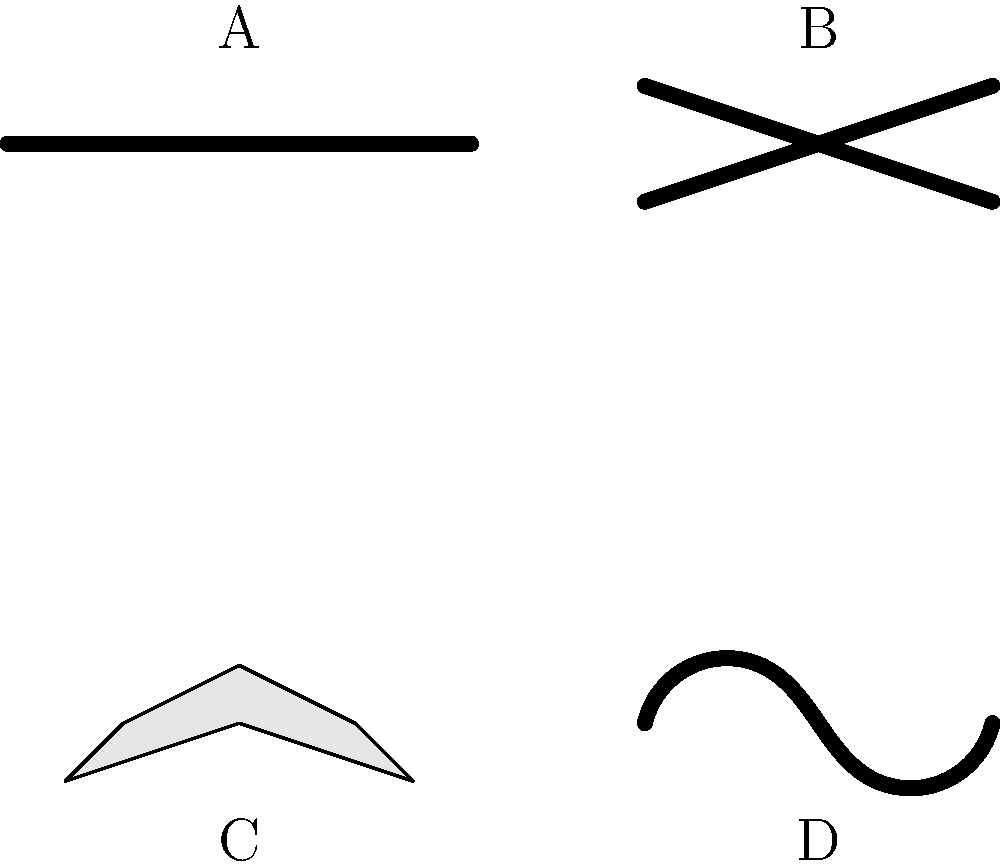As a chef, you understand the importance of pasta shapes in various dishes. Based on the visual appearance of the pasta shapes shown in the image, which one would be best suited for a hearty meat sauce due to its ability to hold the sauce well? To determine which pasta shape is best suited for a hearty meat sauce, we need to consider the characteristics of each shape and how they interact with sauce:

1. Shape A (Spaghetti): Long, thin strands. Good for light, oil-based sauces but not ideal for thick meat sauces.

2. Shape B (Penne): Cylindrical with ridges and hollow center. Good for chunky sauces as the ridges and hollow center can trap sauce.

3. Shape C (Farfalle): Bow-tie or butterfly shape. Better for light sauces or salads, not ideal for thick meat sauces.

4. Shape D (Fusilli): Spiral shape with twists and turns. Excellent for holding thick sauces in its grooves.

Among these options, the fusilli (Shape D) is best suited for a hearty meat sauce. Its spiral shape creates numerous nooks and crannies that can hold onto thick, chunky sauces, ensuring that each bite is full of flavor. The twists also provide a pleasant texture that complements the meat sauce well.
Answer: Fusilli (Shape D) 